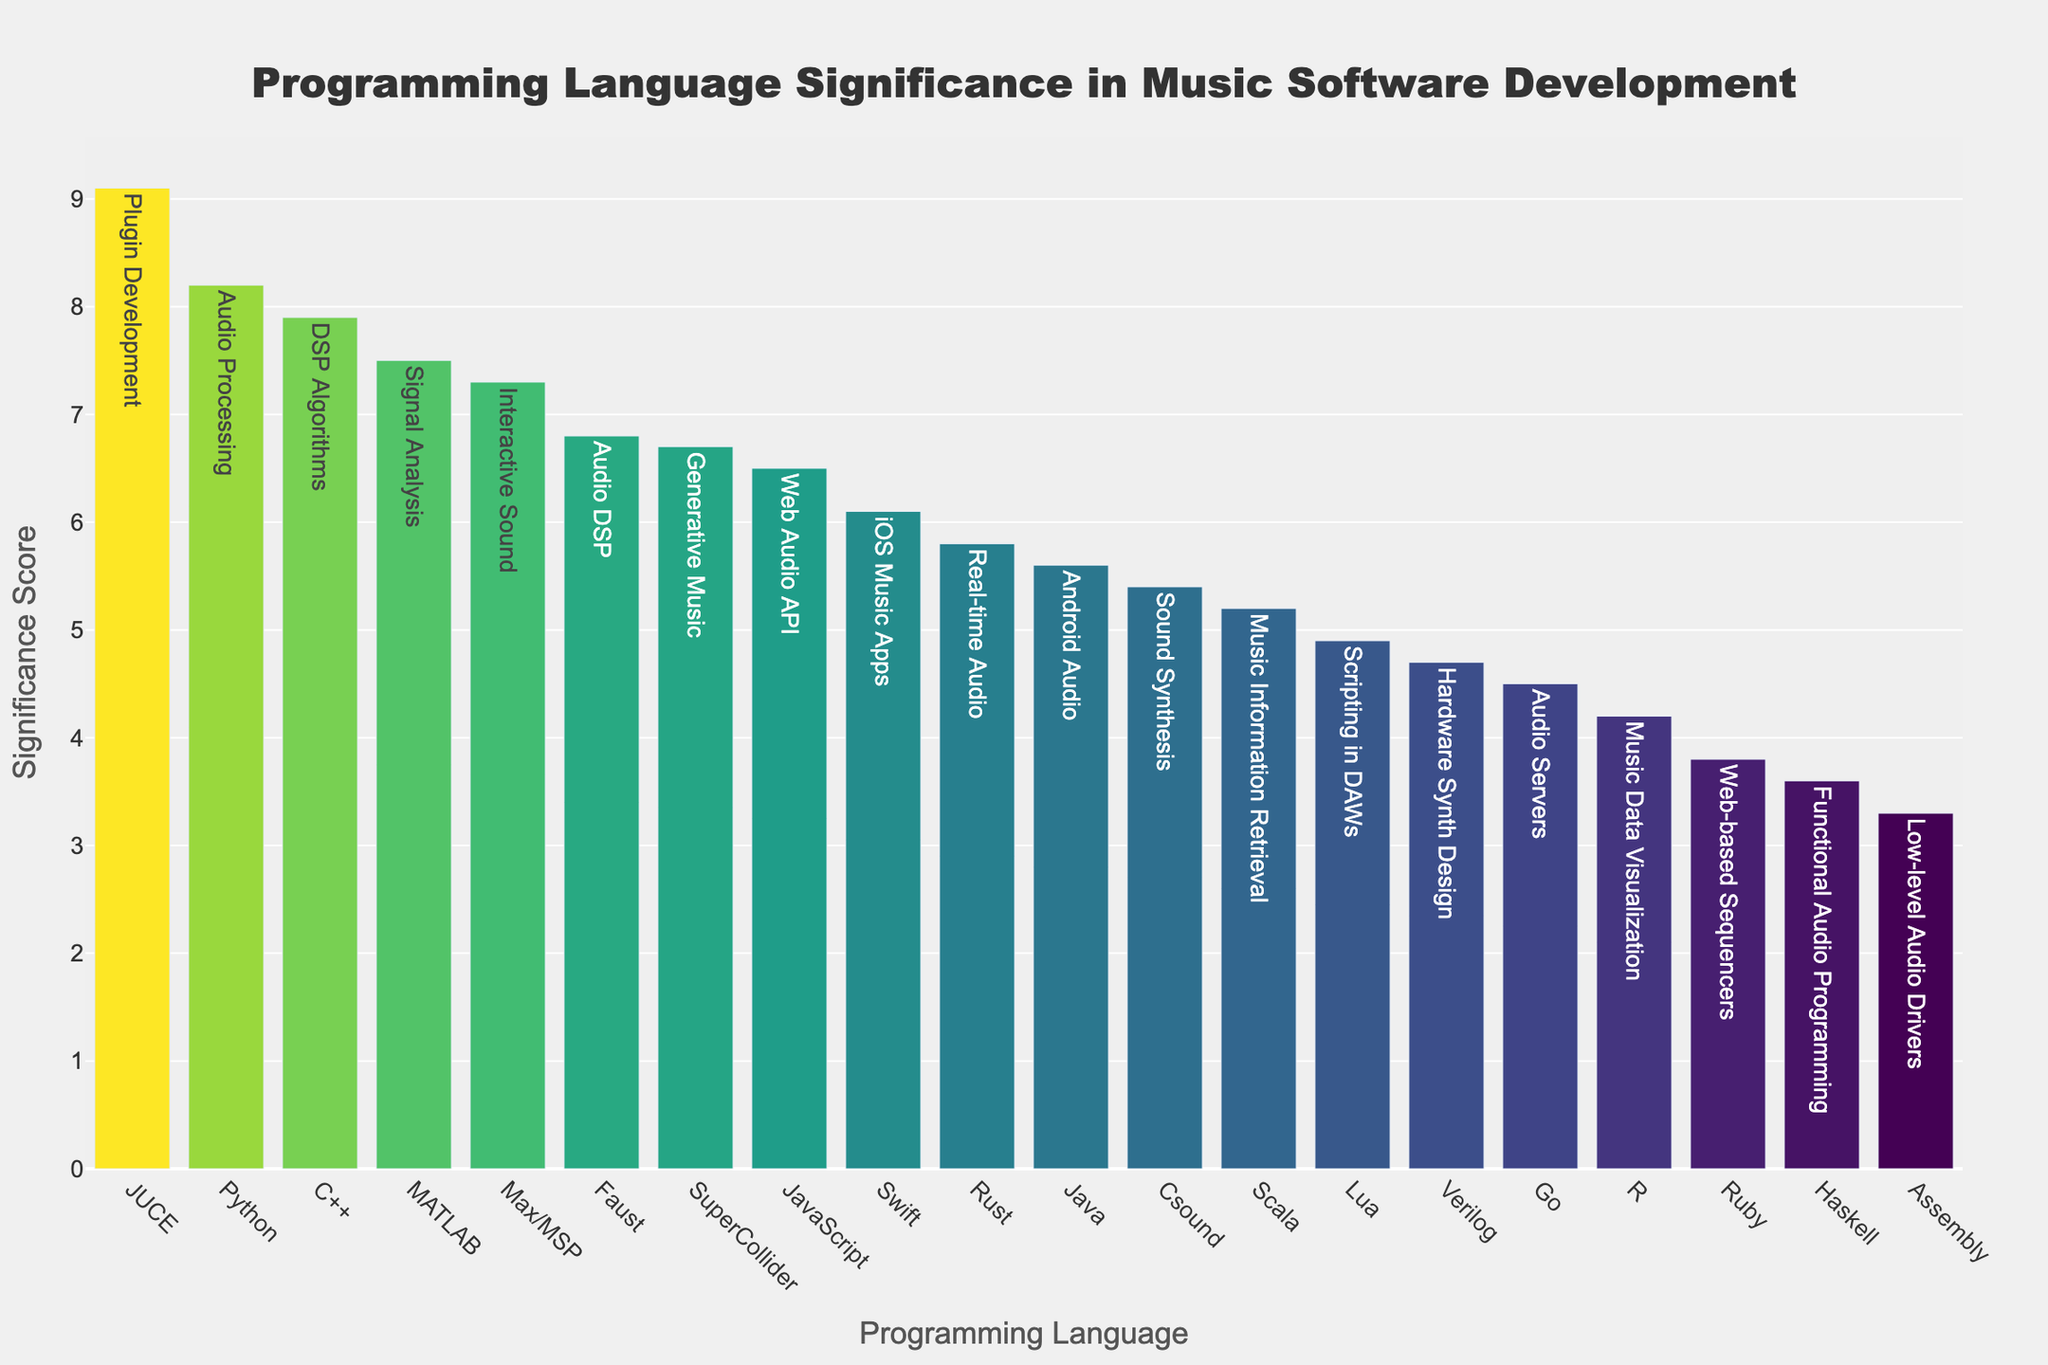What is the title of the plot? The title of the plot is located at the top center of the figure. It provides a summary of what the plot represents.
Answer: "Programming Language Significance in Music Software Development" Which programming language has the highest significance score, and what task is it associated with? The programming language with the highest bar and the corresponding task it is associated with represent the highest significance score in the plot.
Answer: JUCE, Plugin Development How many programming languages have a significance score greater than 7.0? To determine this, count the number of bars that extend above the 7.0 significance score on the y-axis.
Answer: 6 What is the exact significance score for SuperCollider, and what task is it used for? Locate the bar for SuperCollider and refer to the height of the bar and the hover text to confirm the task and significance score.
Answer: 6.7, Generative Music Compare the significance scores of Python and C++. Which one is higher and by how much? Identify the bars corresponding to Python and C++. Note their significance scores and subtract the smaller score from the larger one to find the difference.
Answer: Python is higher by 0.3 What is the median significance score among all programming languages in the plot? To find the median, list all significance scores in numerical order and identify the middle value. With an even number of scores, average the two middle values. (The sorted scores are: 3.3, 3.6, 3.8, 4.2, 4.5, 4.7, 4.9, 5.2, 5.4, 5.6, 5.8, 6.1, 6.5, 6.7, 6.8, 7.3, 7.5, 7.9, 8.2, 9.1)
Answer: 5.55 Which programming language has the lowest significance score, and what task is it associated with? Identify the bar with the lowest height and refer to the associated programming language and task.
Answer: Assembly, Low-level Audio Drivers Calculate the average significance score of programming languages used for web-related tasks (JavaScript and Ruby). Sum the significance scores of JavaScript and Ruby and divide by the number of languages (2). (6.5 + 3.8) / 2 = 5.15
Answer: 5.15 Among the tasks related to audio processing (including Python, C++, Rust, and DSP algorithms), which language scores the lowest? Compare the significance scores of Python, C++, and Rust. Identify the one with the lowest score.
Answer: Rust What programming language is used for iOS music apps, and how does its significance score compare to the language used for Android audio? Refer to the bars for Swift and Java. Compare their significance scores. Swift is associated with iOS music apps and has a significance score of 6.1, while Java is used for Android audio with a score of 5.6.
Answer: Swift is higher by 0.5 